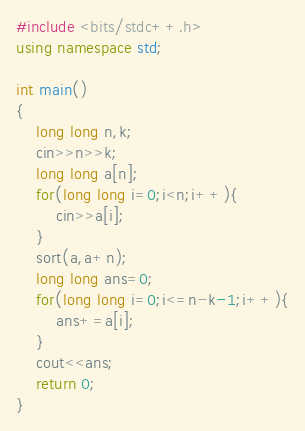Convert code to text. <code><loc_0><loc_0><loc_500><loc_500><_C++_>#include <bits/stdc++.h>
using namespace std;

int main()
{
    long long n,k;
    cin>>n>>k;
    long long a[n];
    for(long long i=0;i<n;i++){
        cin>>a[i];
    }
    sort(a,a+n);
    long long ans=0;
    for(long long i=0;i<=n-k-1;i++){
        ans+=a[i];
    }
    cout<<ans;
    return 0;
}
</code> 